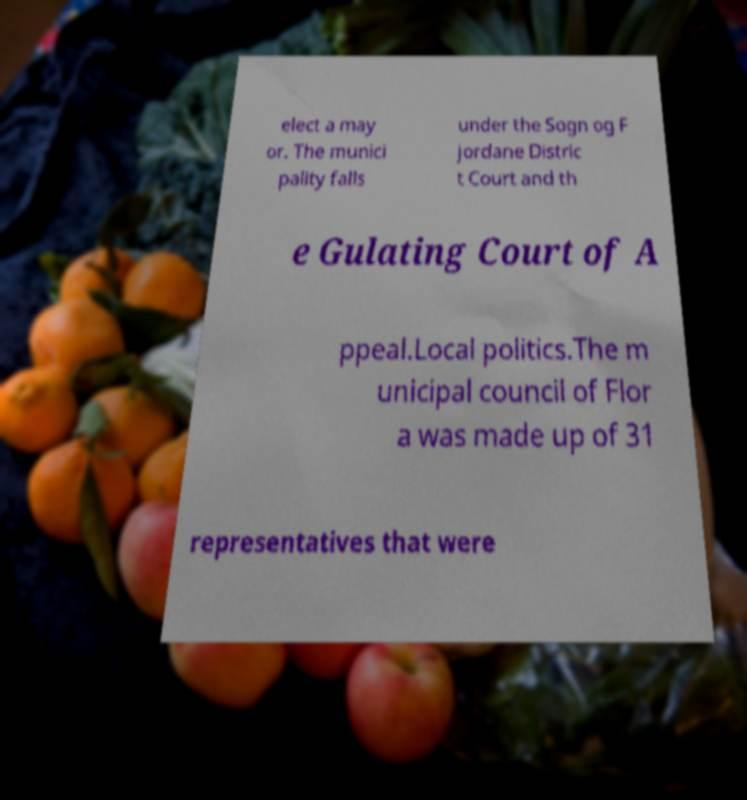Can you accurately transcribe the text from the provided image for me? elect a may or. The munici pality falls under the Sogn og F jordane Distric t Court and th e Gulating Court of A ppeal.Local politics.The m unicipal council of Flor a was made up of 31 representatives that were 